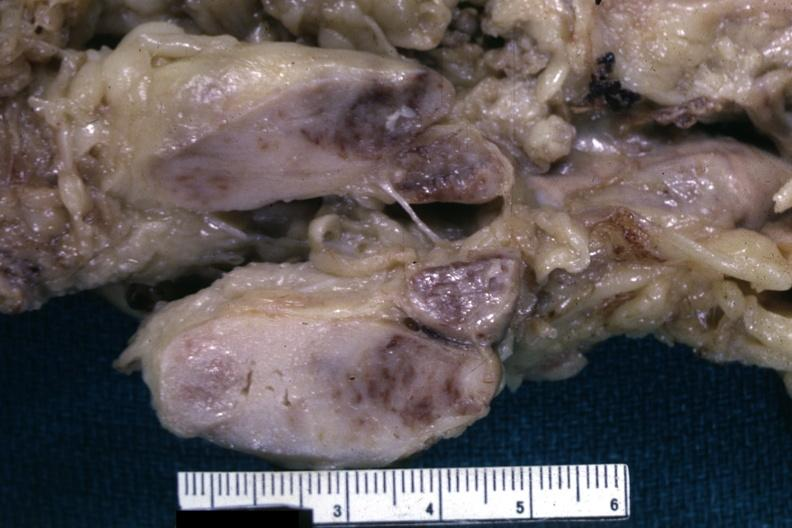what is liver lesion?
Answer the question using a single word or phrase. Lymphoma 